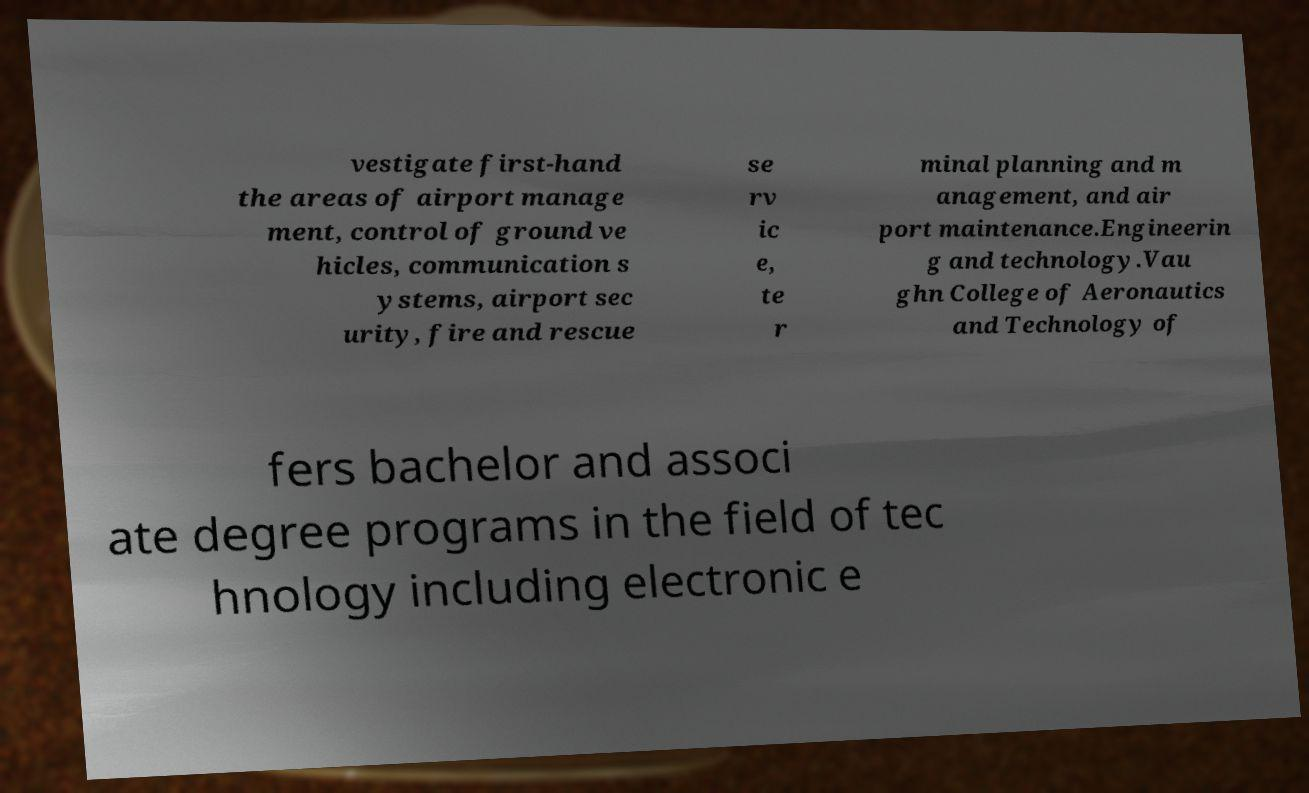Could you extract and type out the text from this image? vestigate first-hand the areas of airport manage ment, control of ground ve hicles, communication s ystems, airport sec urity, fire and rescue se rv ic e, te r minal planning and m anagement, and air port maintenance.Engineerin g and technology.Vau ghn College of Aeronautics and Technology of fers bachelor and associ ate degree programs in the field of tec hnology including electronic e 